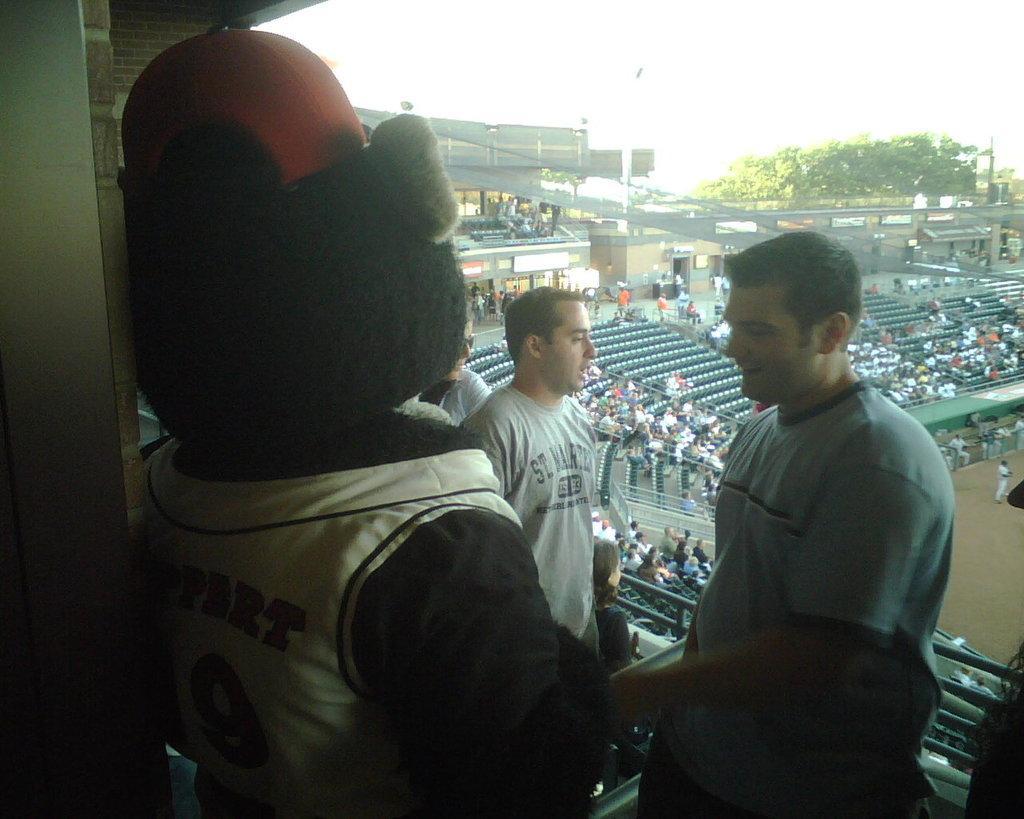How would you summarize this image in a sentence or two? In this image we can see there is an inside view of the stadium. And there are a few people standing on the floor and few people on the chair. And there is a doll near the wall. There are trees, pole, railing and the sky. 